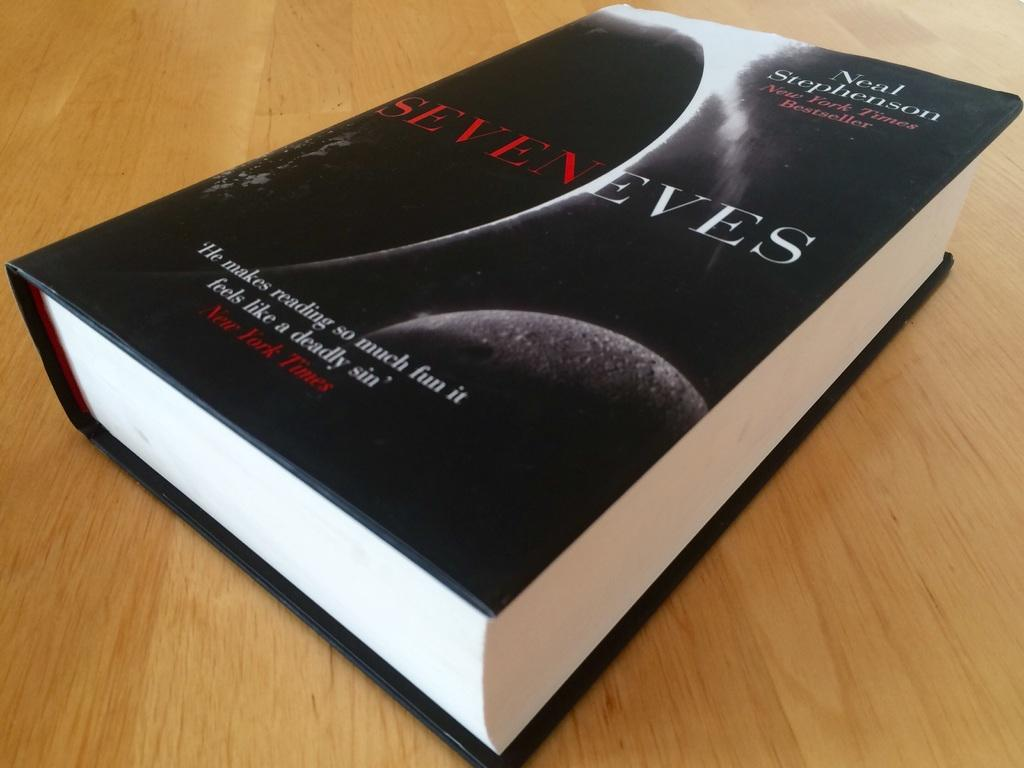<image>
Create a compact narrative representing the image presented. black covered book titled Seven Eves sits on a wood surface/ 